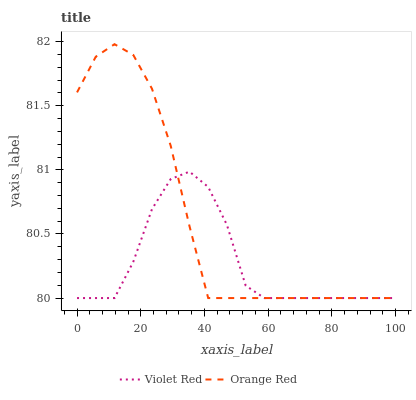Does Violet Red have the minimum area under the curve?
Answer yes or no. Yes. Does Orange Red have the maximum area under the curve?
Answer yes or no. Yes. Does Orange Red have the minimum area under the curve?
Answer yes or no. No. Is Orange Red the smoothest?
Answer yes or no. Yes. Is Violet Red the roughest?
Answer yes or no. Yes. Is Orange Red the roughest?
Answer yes or no. No. Does Violet Red have the lowest value?
Answer yes or no. Yes. Does Orange Red have the highest value?
Answer yes or no. Yes. Does Orange Red intersect Violet Red?
Answer yes or no. Yes. Is Orange Red less than Violet Red?
Answer yes or no. No. Is Orange Red greater than Violet Red?
Answer yes or no. No. 